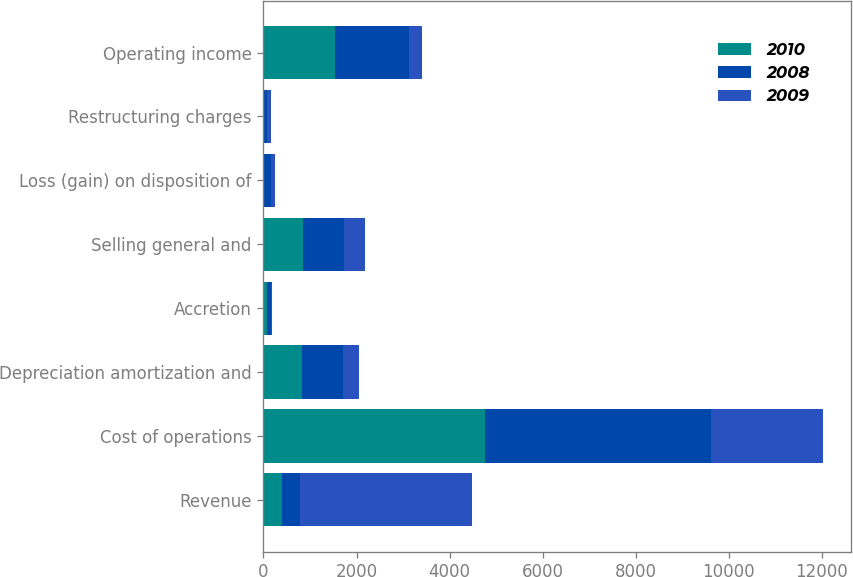Convert chart to OTSL. <chart><loc_0><loc_0><loc_500><loc_500><stacked_bar_chart><ecel><fcel>Revenue<fcel>Cost of operations<fcel>Depreciation amortization and<fcel>Accretion<fcel>Selling general and<fcel>Loss (gain) on disposition of<fcel>Restructuring charges<fcel>Operating income<nl><fcel>2010<fcel>394.4<fcel>4764.8<fcel>833.7<fcel>80.5<fcel>858<fcel>19.1<fcel>11.4<fcel>1539.1<nl><fcel>2008<fcel>394.4<fcel>4844.2<fcel>869.7<fcel>88.8<fcel>880.4<fcel>137<fcel>63.2<fcel>1589.8<nl><fcel>2009<fcel>3685.1<fcel>2416.7<fcel>354.1<fcel>23.9<fcel>434.7<fcel>89.8<fcel>82.7<fcel>283.2<nl></chart> 